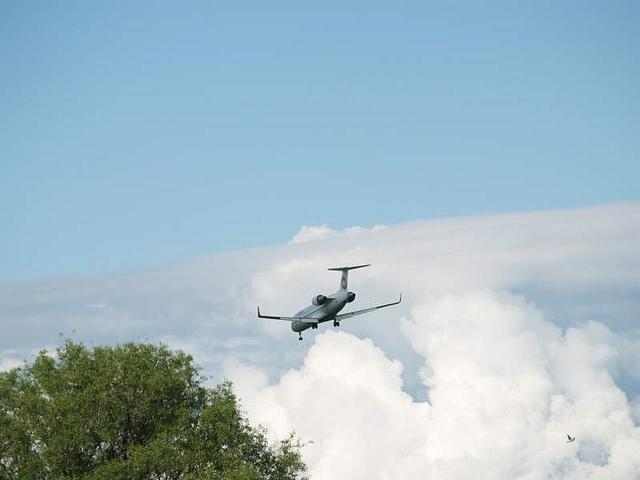How many trees are in the picture?
Give a very brief answer. 1. How many birds are there?
Give a very brief answer. 1. How many planes are leaving a trail?
Give a very brief answer. 1. How many airplanes are there?
Give a very brief answer. 1. How many objects in the sky?
Give a very brief answer. 1. 